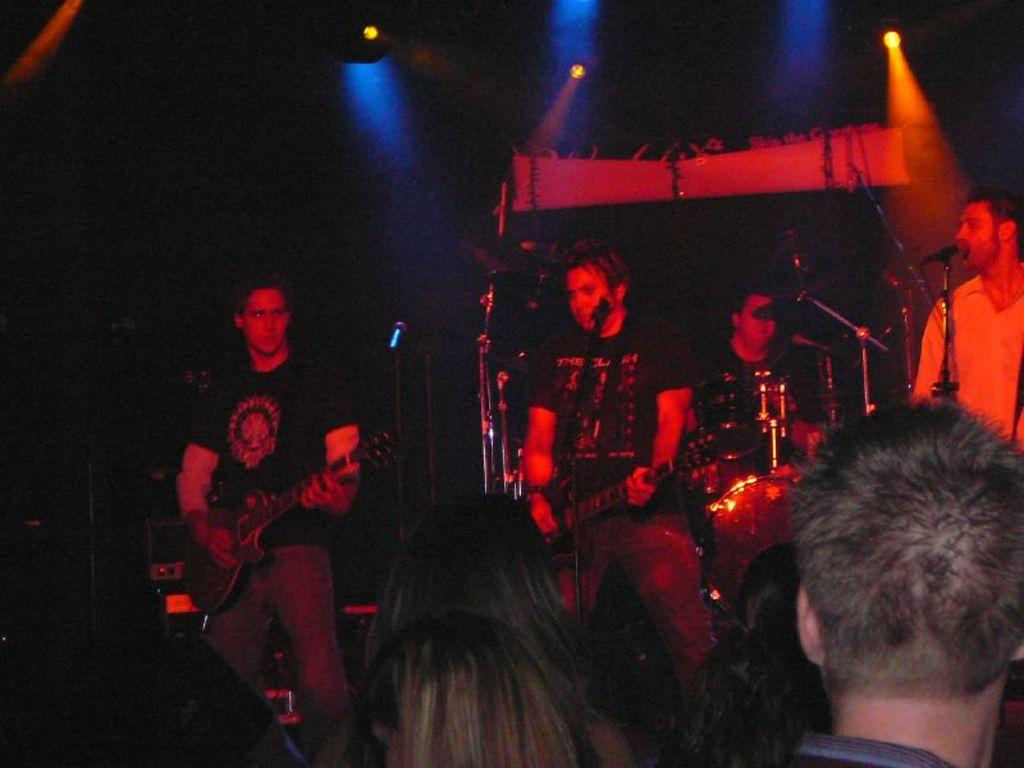How many people are on the stage in the image? There are four persons on the stage. What are two of the persons doing on the stage? Two of the persons are playing guitar. What else can be seen in the image besides the people on stage? There are musical instruments in the image. What can be seen in the background of the image? There are lights visible in the background. What type of alarm is going off in the image? There is no alarm present in the image. Can you describe the mint-flavored item in the image? There is no mint-flavored item present in the image. 